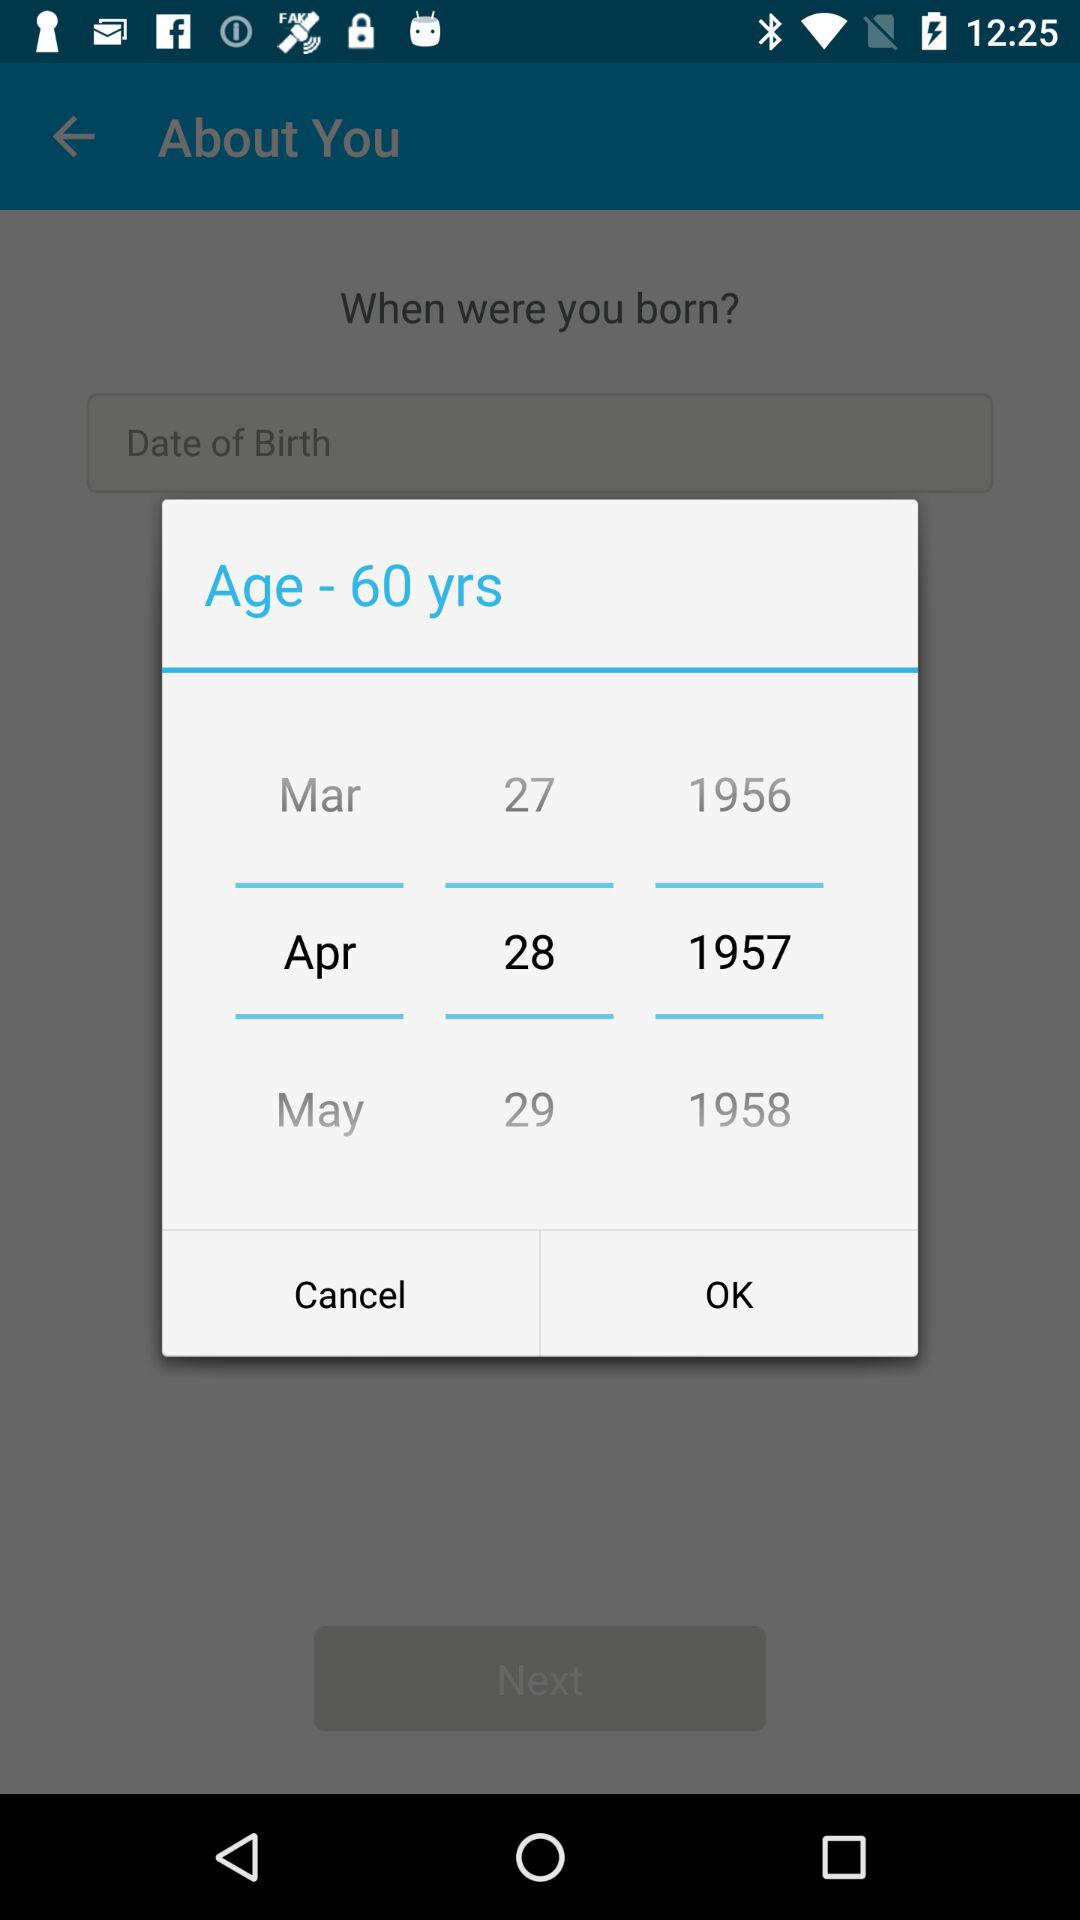How many years are shown?
When the provided information is insufficient, respond with <no answer>. <no answer> 